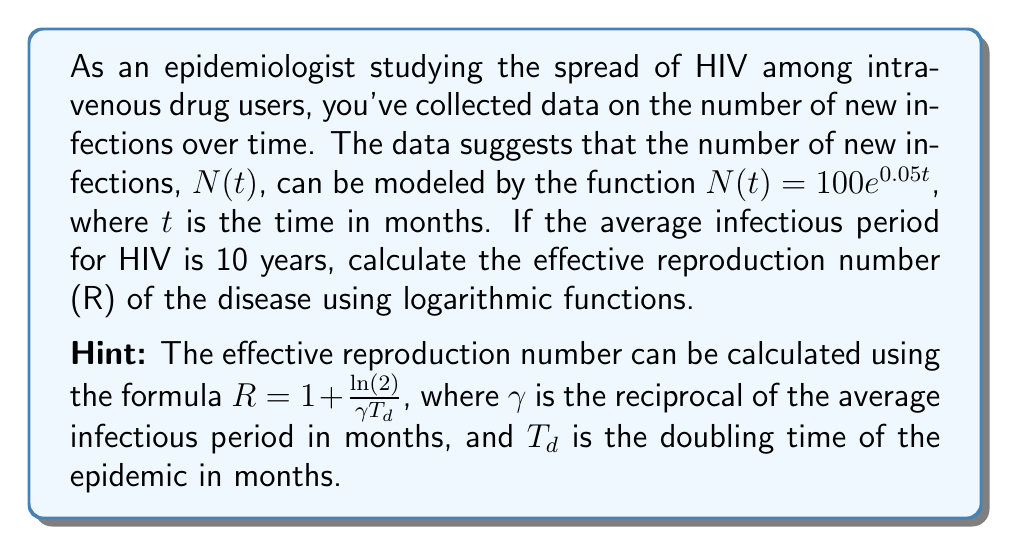Give your solution to this math problem. To solve this problem, we need to follow these steps:

1) First, we need to calculate $\gamma$:
   $\gamma = \frac{1}{\text{average infectious period in months}}$
   $\gamma = \frac{1}{10 \times 12} = \frac{1}{120}$ months$^{-1}$

2) Next, we need to find the doubling time $T_d$. We can use the given function $N(t) = 100e^{0.05t}$ to do this:
   
   At $t = 0$: $N(0) = 100$
   At doubling: $N(T_d) = 200 = 100e^{0.05T_d}$

   Dividing both sides by 100:
   $2 = e^{0.05T_d}$

   Taking natural log of both sides:
   $\ln(2) = 0.05T_d$

   Solving for $T_d$:
   $T_d = \frac{\ln(2)}{0.05} \approx 13.86$ months

3) Now we can use the formula for the effective reproduction number:

   $R = 1 + \frac{\ln(2)}{\gamma T_d}$

   Substituting the values we found:

   $R = 1 + \frac{\ln(2)}{\frac{1}{120} \times 13.86}$

4) Simplify:
   $R = 1 + \frac{120 \ln(2)}{13.86} \approx 7.02$
Answer: The effective reproduction number (R) of the disease is approximately 7.02. 